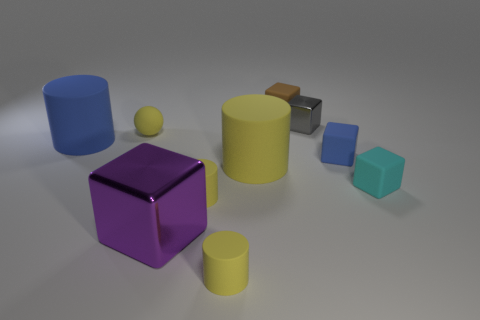How many yellow cylinders must be subtracted to get 1 yellow cylinders? 2 Subtract all small brown cubes. How many cubes are left? 4 Subtract all red cubes. How many yellow cylinders are left? 3 Subtract all cyan blocks. How many blocks are left? 4 Subtract 3 cubes. How many cubes are left? 2 Subtract all cylinders. How many objects are left? 6 Subtract all purple cylinders. Subtract all green blocks. How many cylinders are left? 4 Subtract all small purple cubes. Subtract all gray things. How many objects are left? 9 Add 6 small matte cylinders. How many small matte cylinders are left? 8 Add 7 yellow balls. How many yellow balls exist? 8 